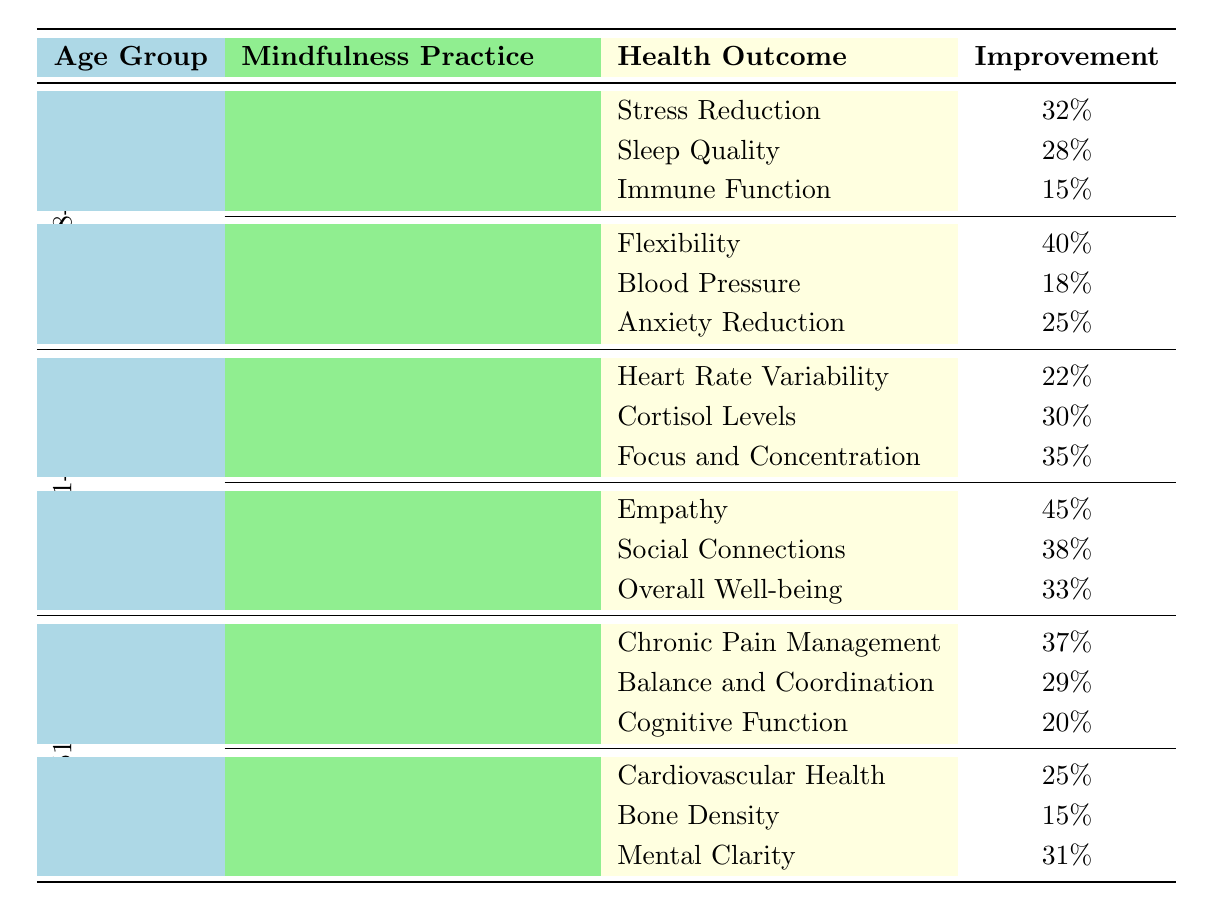What mindfulness practice shows the highest improvement in flexibility in the 18-30 age group? In the 18-30 age group, the mindfulness practice that shows the highest improvement in flexibility is Yoga, with an improvement of 40%.
Answer: Yoga Which age group has the highest percentage improvement in empathy? The age group 31-50 shows the highest percentage improvement in empathy, with a value of 45% from the practice of Loving-Kindness Meditation.
Answer: 31-50 What is the average improvement of health outcomes from the Body Scan practice for the 51+ age group? The improvements listed under Body Scan are 37%, 29%, and 20%. Calculating the average: (37 + 29 + 20) / 3 = 28.67%.
Answer: 28.67% Is there any mindfulness practice in the 51+ age group that improves bone density? Yes, Zen Walking in the 51+ age group shows an improvement in bone density with a value of 15%.
Answer: Yes Which health outcome has the lowest improvement overall across all age groups and practices? The lowest improvement is in Bone Density from the Zen Walking practice in the 51+ age group, with an improvement of 15%.
Answer: Bone Density How does the improvement of stress reduction in the 18-30 age group compare to the improvement of anxiety reduction in the same age group? Stress Reduction improves by 32%, while Anxiety Reduction improves by 25%. Stress Reduction is greater (32% > 25%).
Answer: Stress Reduction What is the total percentage improvement for all health outcomes under Mindful Breathing in the 31-50 age group? The improvements for Mindful Breathing are 22%, 30%, and 35%. Adding them gives: 22 + 30 + 35 = 87%.
Answer: 87% Is Loving-Kindness Meditation beneficial for social connections in the 31-50 age group? Yes, Loving-Kindness Meditation improves social connections with a percentage improvement of 38% in the 31-50 age group.
Answer: Yes What improvements can be seen in mental clarity and cognitive function under practices for the 51+ age group? For the 51+ age group, Zen Walking improves mental clarity by 31%, and Body Scan improves cognitive function by 20%.
Answer: Mental Clarity 31%, Cognitive Function 20% In which group does Mindfulness practice yield the highest improvement in cortisol levels? The 31-50 age group shows the highest improvement in cortisol levels with a percentage of 30% from the Mindful Breathing practice.
Answer: 31-50 